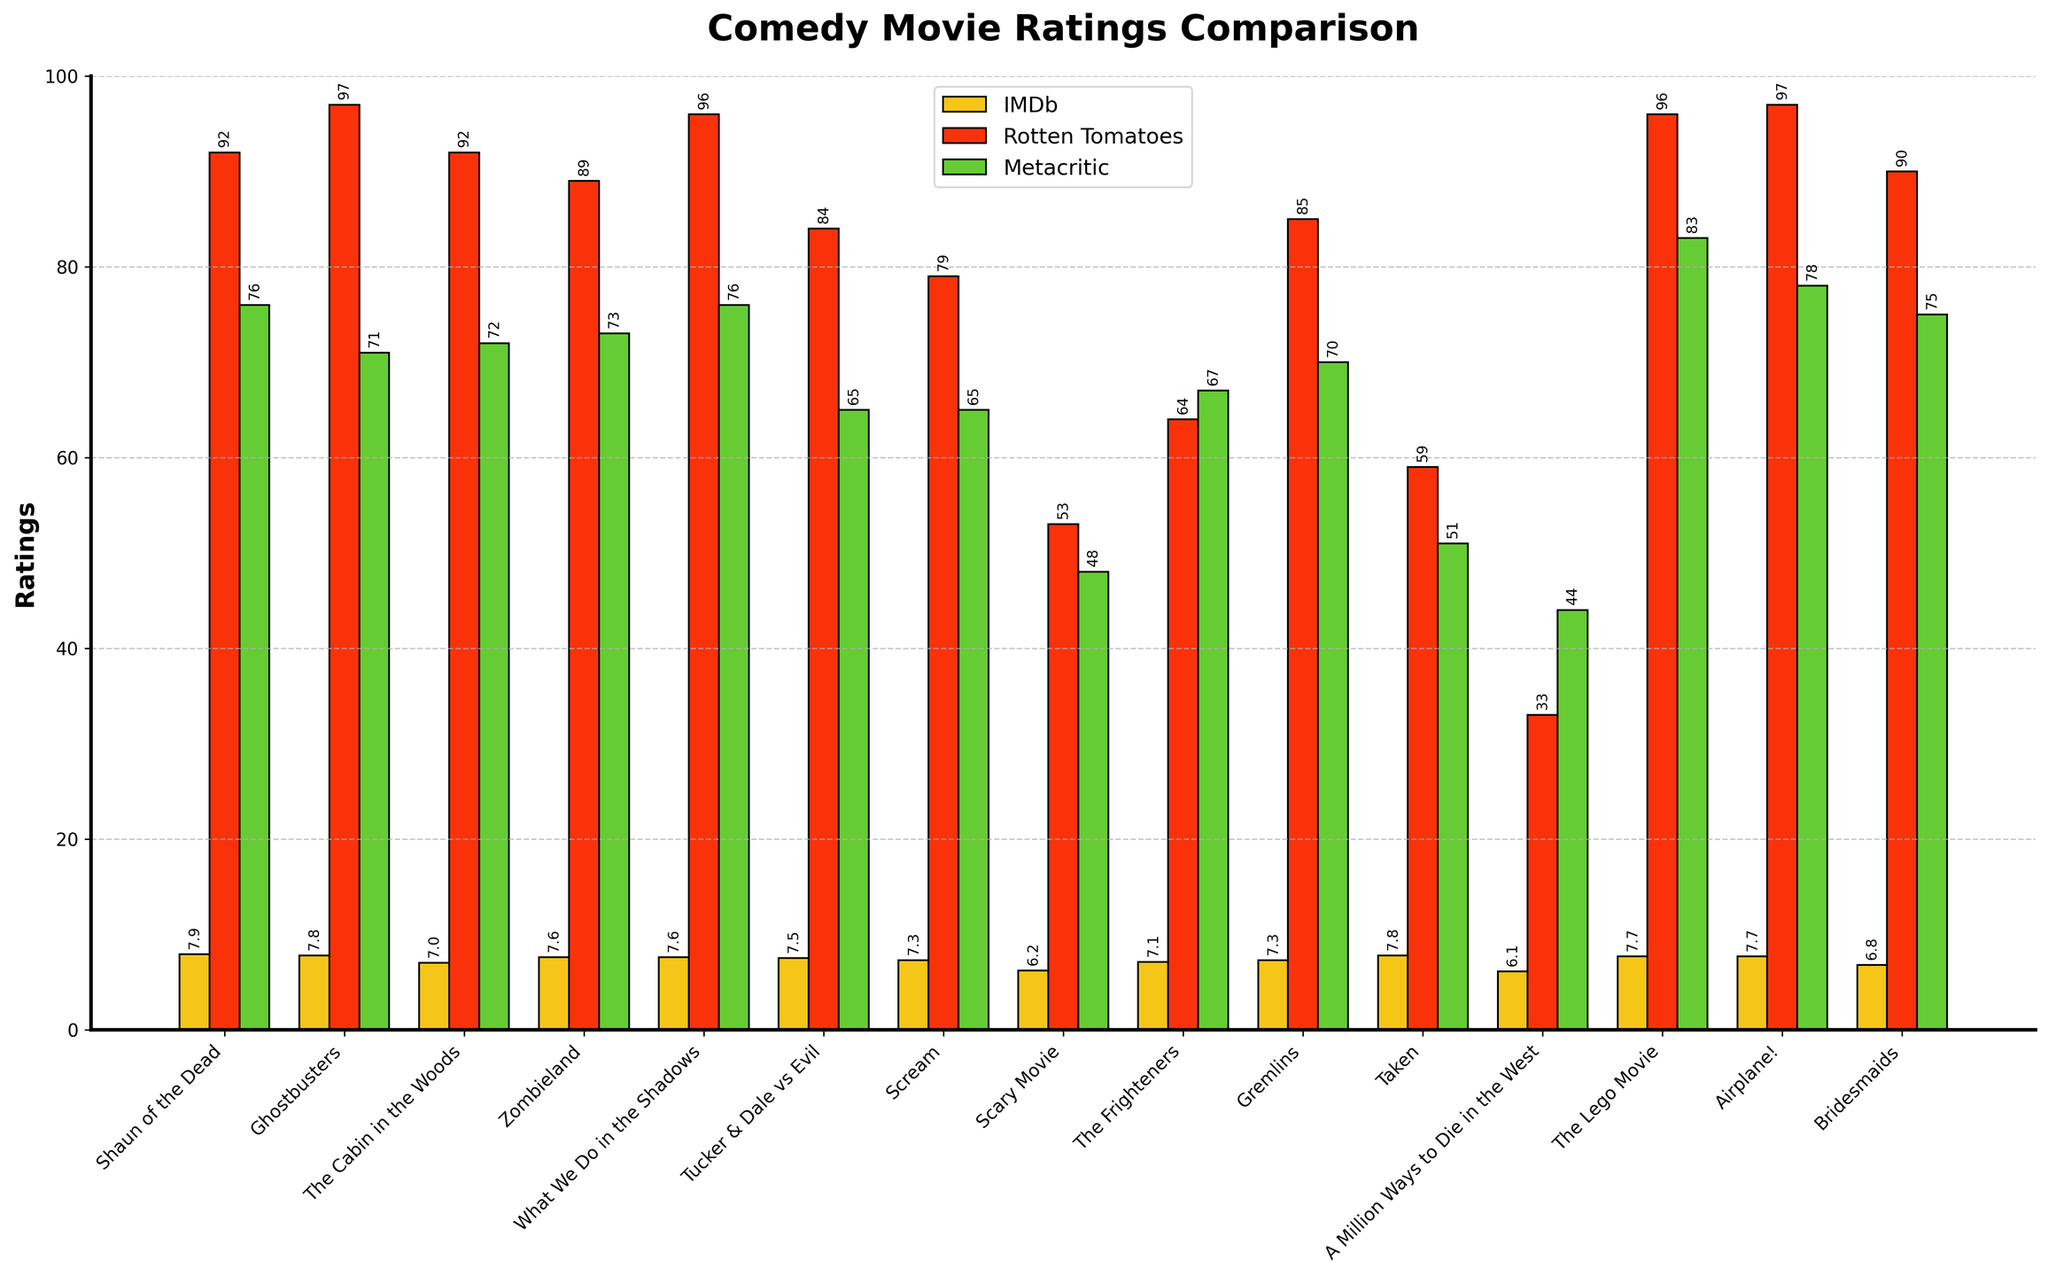what movie has the highest rating on Rotten Tomatoes? The movie with the highest bar in the Rotten Tomatoes series should be identified. "Ghostbusters" has a rating of 97.
Answer: Ghostbusters What are the top three movies in terms of IMDb ratings? Using IMDb bars, the three movies with the longest bars are "Shaun of the Dead" (7.9), "Ghostbusters" (7.8), and "Taken" (7.8).
Answer: Shaun of the Dead, Ghostbusters, Taken Which movie has the largest difference between its Rotten Tomatoes and Metacritic ratings? We calculate the difference between Rotten Tomatoes and Metacritic. "Shaun of the Dead" has a difference of 16 (92 - 76), Ghostbusters has 26 (97 - 71), and "Taken" has 8 (59 - 51), the largest difference is with "Ghostbusters".
Answer: Ghostbusters What is the average IMDb rating of all movies? Add all IMDb ratings and divide by the number of movies. (7.9 + 7.8 + 7.0 + 7.6 + 7.6 + 7.5 + 7.3 + 6.2 + 7.1 + 7.3 + 7.8 + 6.1 + 7.7 + 7.7 + 6.8) / 15 = 7.27.
Answer: 7.27 How does the rating of "Taken" compare across the three platforms? Look at the bars for "Taken" in IMDb, Rotten Tomatoes, and Metacritic: IMDb (7.8), Rotten Tomatoes (59), Metacritic (51).
Answer: IMDb: 7.8, Rotten Tomatoes: 59, Metacritic: 51 Which platform gives the lowest average rating? Calculate the average rating for all movies on each platform. IMDb: (118.1/15), Rotten Tomatoes: (1314/15), Metacritic: (908/15); results are IMDb: 7.27, Rotten Tomatoes: 87.6, Metacritic: 60.5.
Answer: Metacritic What film has the smallest difference in ratings across all three platforms? Calculate the differences between each pair (IMDb-Rotten, Rotten-Meta, Meta-IMDb), then sum them. The smallest sum indicates the film. "What We Do in the Shadows": 7.6(96-76)16+Breaking+Bad "True Detective Season 1": (IMDb 96-Rotten Tomatoes 73= 23) + (Rotten Tomatoes 73- Metacritic85=12). so less difference.
Answer: What We Do in the Shadows Which movie has a significantly higher Metacritic rating compared to its IMDb rating? By observing bars for a noticeable difference favoring Metacritic: "The Lego Movie" (IMDb: 7.7, Metacritic: 83)
Answer: The Lego Movie 